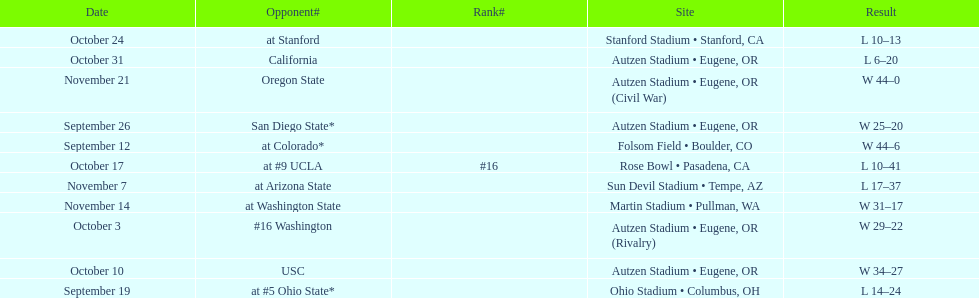What is the number of away games ? 6. 